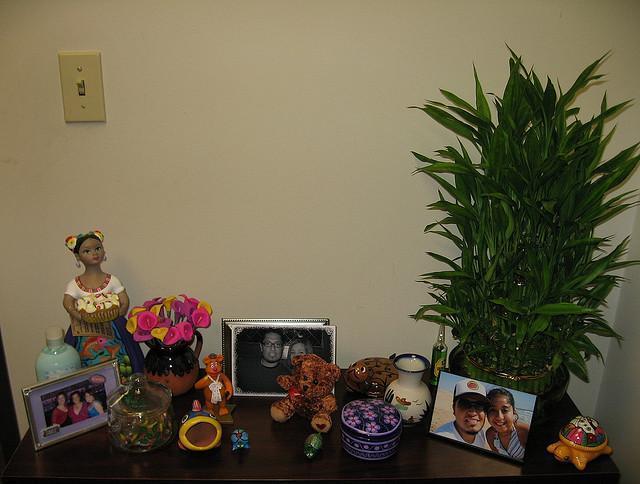How many teddy bears are in the image?
Give a very brief answer. 1. How many bears are on the table?
Give a very brief answer. 2. How many bears are in the picture?
Give a very brief answer. 1. How many bears are wearing pants?
Give a very brief answer. 0. How many hats are there?
Give a very brief answer. 1. How many trees on the table?
Give a very brief answer. 1. How many people are there?
Give a very brief answer. 2. How many vases can be seen?
Give a very brief answer. 4. 